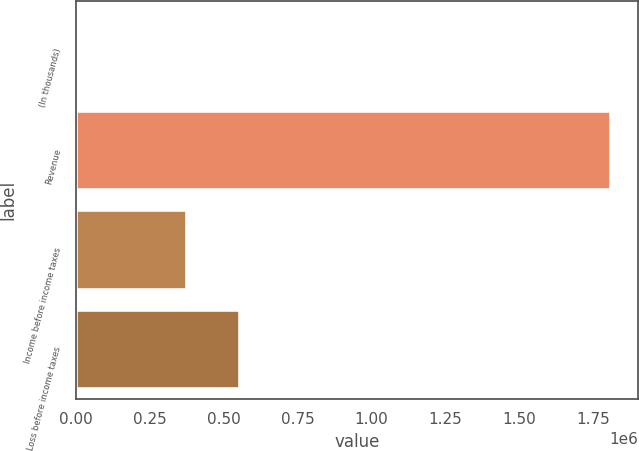Convert chart to OTSL. <chart><loc_0><loc_0><loc_500><loc_500><bar_chart><fcel>(In thousands)<fcel>Revenue<fcel>Income before income taxes<fcel>Loss before income taxes<nl><fcel>2008<fcel>1.81081e+06<fcel>374738<fcel>555618<nl></chart> 